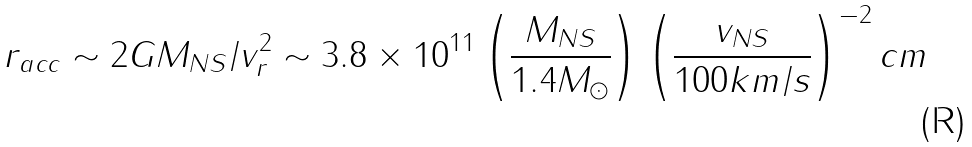<formula> <loc_0><loc_0><loc_500><loc_500>r _ { a c c } \sim 2 G M _ { N S } / v _ { r } ^ { 2 } \sim 3 . 8 \times 1 0 ^ { 1 1 } \left ( \frac { M _ { N S } } { 1 . 4 M _ { \odot } } \right ) \left ( \frac { v _ { N S } } { 1 0 0 k m / s } \right ) ^ { - 2 } c m</formula> 